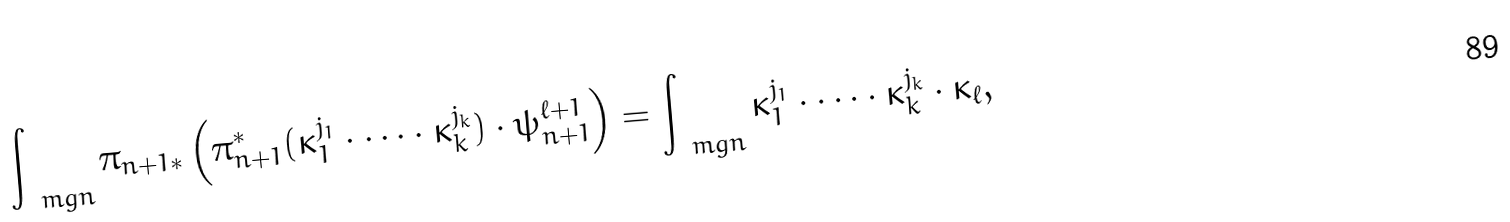<formula> <loc_0><loc_0><loc_500><loc_500>\int _ { \ m g n } \pi _ { n + 1 * } \left ( \pi _ { n + 1 } ^ { * } ( \kappa _ { 1 } ^ { j _ { 1 } } \cdot \dots \cdot \kappa _ { k } ^ { j _ { k } } ) \cdot \psi _ { n + 1 } ^ { \ell + 1 } \right ) = \int _ { \ m g n } \kappa _ { 1 } ^ { j _ { 1 } } \cdot \dots \cdot \kappa _ { k } ^ { j _ { k } } \cdot \kappa _ { \ell } ,</formula> 